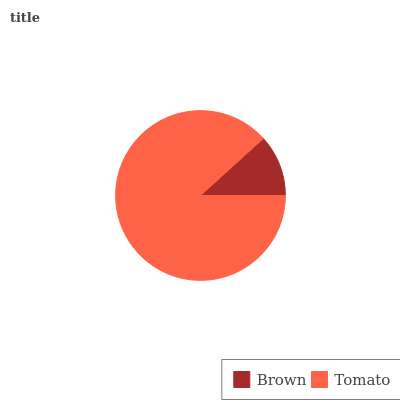Is Brown the minimum?
Answer yes or no. Yes. Is Tomato the maximum?
Answer yes or no. Yes. Is Tomato the minimum?
Answer yes or no. No. Is Tomato greater than Brown?
Answer yes or no. Yes. Is Brown less than Tomato?
Answer yes or no. Yes. Is Brown greater than Tomato?
Answer yes or no. No. Is Tomato less than Brown?
Answer yes or no. No. Is Tomato the high median?
Answer yes or no. Yes. Is Brown the low median?
Answer yes or no. Yes. Is Brown the high median?
Answer yes or no. No. Is Tomato the low median?
Answer yes or no. No. 